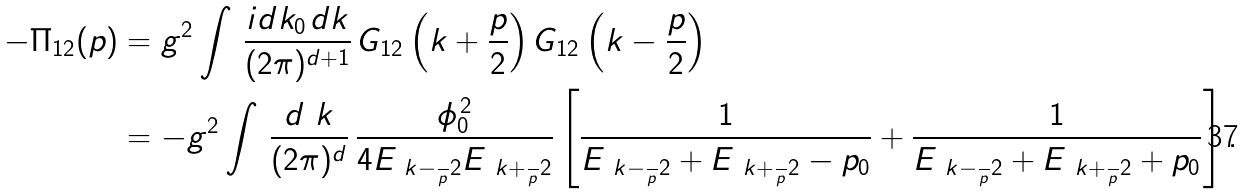<formula> <loc_0><loc_0><loc_500><loc_500>- \Pi _ { 1 2 } ( p ) & = g ^ { 2 } \int \, \frac { i d k _ { 0 \, } d k } { ( 2 \pi ) ^ { d + 1 } } \, G _ { 1 2 } \left ( k + \frac { p } { 2 } \right ) G _ { 1 2 } \left ( k - \frac { p } { 2 } \right ) \\ & = - g ^ { 2 } \int \, \frac { d \ k } { ( 2 \pi ) ^ { d } } \, \frac { \phi _ { 0 } ^ { \, 2 } } { 4 E _ { \ k - \frac { \ } { p } 2 } E _ { \ k + \frac { \ } { p } 2 } } \left [ \frac { 1 } { E _ { \ k - \frac { \ } { p } 2 } + E _ { \ k + \frac { \ } { p } 2 } - p _ { 0 } } + \frac { 1 } { E _ { \ k - \frac { \ } { p } 2 } + E _ { \ k + \frac { \ } { p } 2 } + p _ { 0 } } \right ] .</formula> 